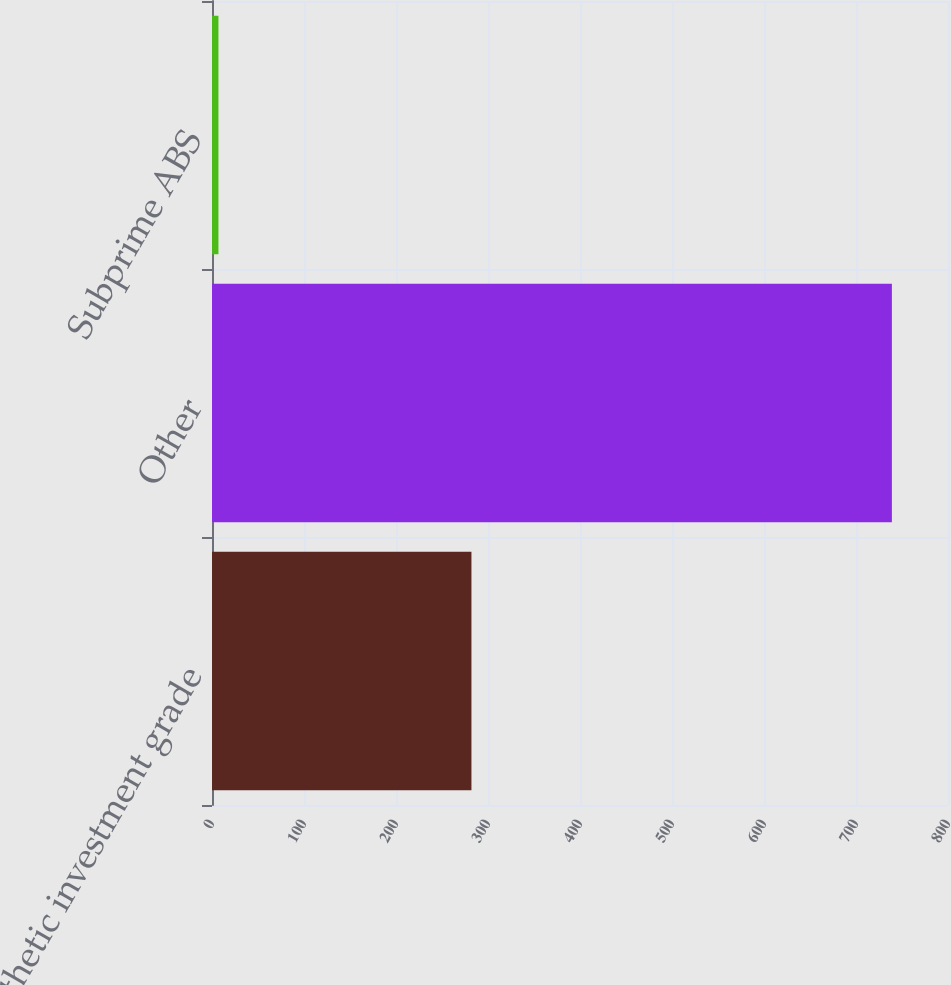Convert chart to OTSL. <chart><loc_0><loc_0><loc_500><loc_500><bar_chart><fcel>Synthetic investment grade<fcel>Other<fcel>Subprime ABS<nl><fcel>282<fcel>739<fcel>7<nl></chart> 